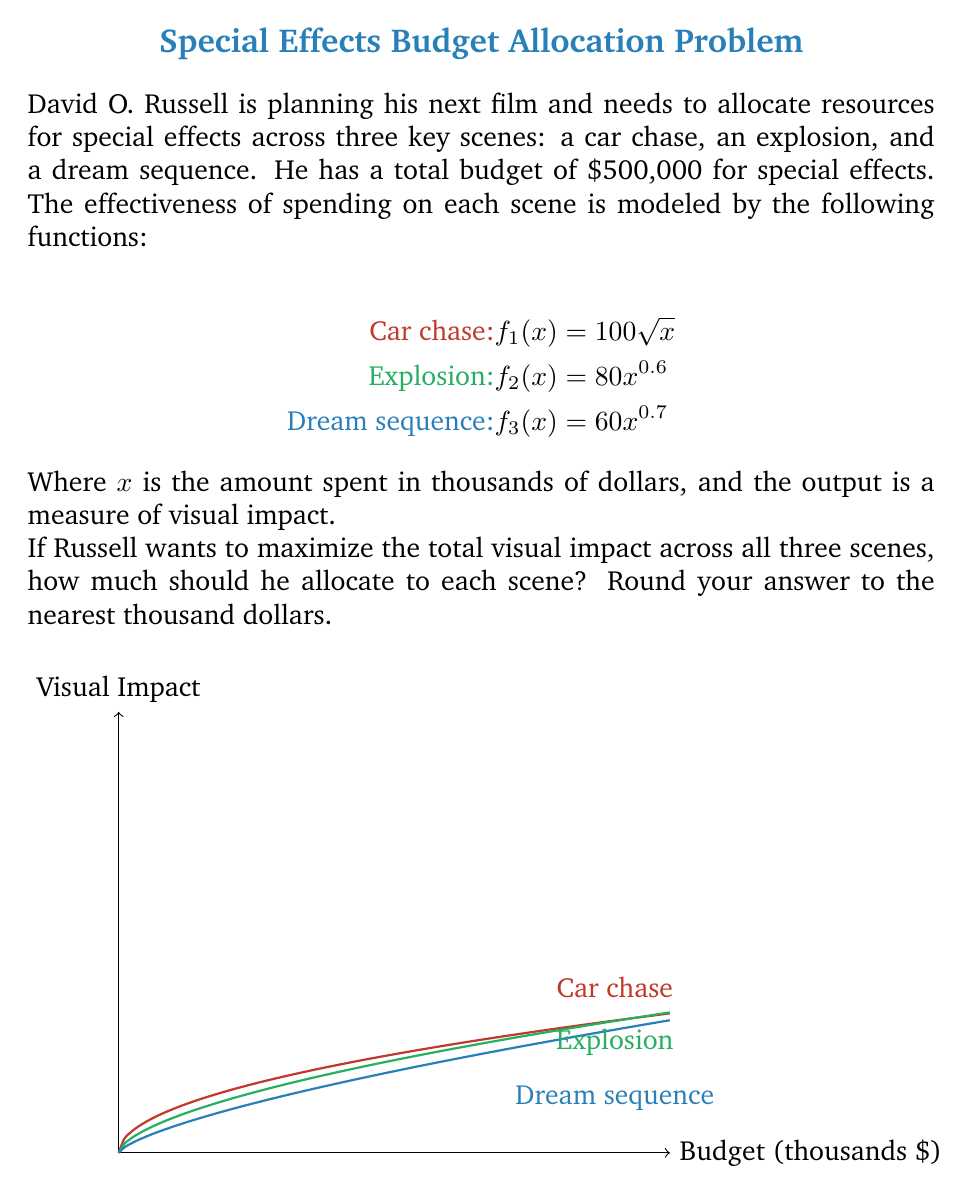Can you answer this question? To solve this problem, we'll use the method of Lagrange multipliers, as we're dealing with a constrained optimization problem.

Step 1: Define the objective function and constraint
Let $x_1$, $x_2$, and $x_3$ be the amounts allocated to the car chase, explosion, and dream sequence respectively.

Objective function: $F = 100\sqrt{x_1} + 80x_2^{0.6} + 60x_3^{0.7}$
Constraint: $g = x_1 + x_2 + x_3 - 500 = 0$

Step 2: Form the Lagrangian
$$L = 100\sqrt{x_1} + 80x_2^{0.6} + 60x_3^{0.7} - \lambda(x_1 + x_2 + x_3 - 500)$$

Step 3: Take partial derivatives and set them to zero
$$\frac{\partial L}{\partial x_1} = \frac{50}{\sqrt{x_1}} - \lambda = 0$$
$$\frac{\partial L}{\partial x_2} = 48x_2^{-0.4} - \lambda = 0$$
$$\frac{\partial L}{\partial x_3} = 42x_3^{-0.3} - \lambda = 0$$
$$\frac{\partial L}{\partial \lambda} = x_1 + x_2 + x_3 - 500 = 0$$

Step 4: Solve the system of equations
From the first three equations:
$$\frac{50}{\sqrt{x_1}} = 48x_2^{-0.4} = 42x_3^{-0.3} = \lambda$$

This gives us:
$$x_1 = \frac{2500}{\lambda^2}, x_2 = \left(\frac{48}{\lambda}\right)^{2.5}, x_3 = \left(\frac{42}{\lambda}\right)^{10/3}$$

Substituting these into the constraint equation:
$$\frac{2500}{\lambda^2} + \left(\frac{48}{\lambda}\right)^{2.5} + \left(\frac{42}{\lambda}\right)^{10/3} = 500$$

This equation can be solved numerically to find $\lambda \approx 3.162$.

Step 5: Calculate the allocations
Using this value of $\lambda$:
$$x_1 \approx 250,000$$
$$x_2 \approx 156,000$$
$$x_3 \approx 94,000$$

Rounding to the nearest thousand dollars:
Car chase: $250,000
Explosion: $156,000
Dream sequence: $94,000
Answer: Car chase: $250,000, Explosion: $156,000, Dream sequence: $94,000 